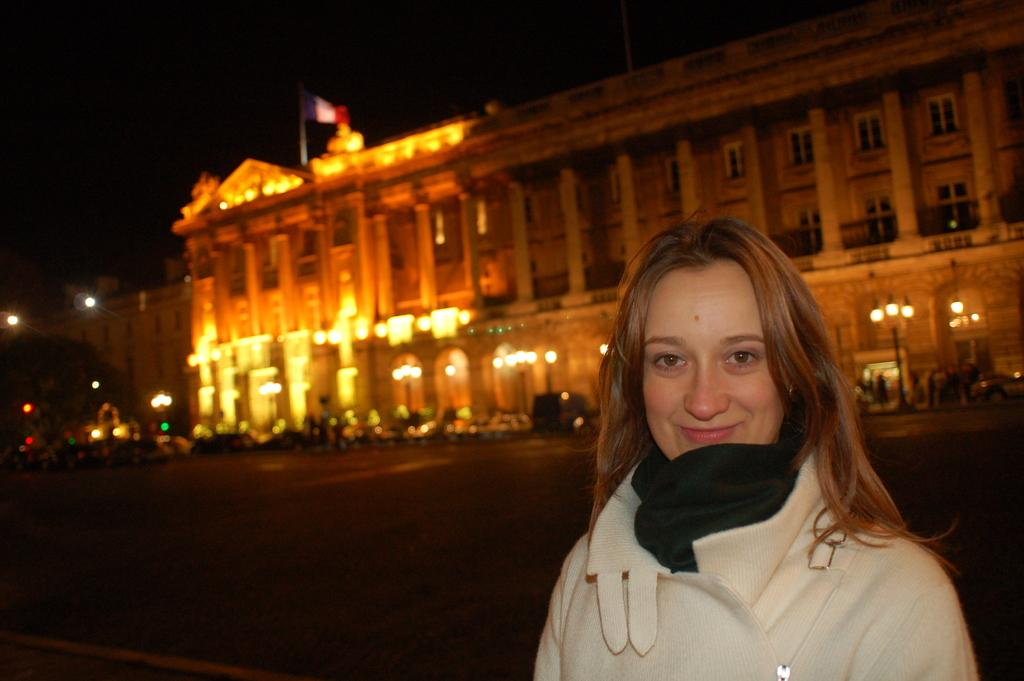Who is present in the image? There is a woman in the image. What is the woman's expression? The woman is smiling. What can be seen in the background of the image? There is a building with lightning, a flag, and a tree in the background. What else is visible in the image? A road is visible in the image. How many flocks of birds are flying in a circle in the image? There are no flocks of birds or circles present in the image. What type of party is happening in the image? There is no party depicted in the image; it features a woman, a background with a building, lightning, flag, and tree, and a road. 